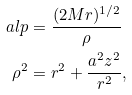Convert formula to latex. <formula><loc_0><loc_0><loc_500><loc_500>\ a l p & = \frac { ( 2 M r ) ^ { 1 / 2 } } { \rho } \\ \rho ^ { 2 } & = r ^ { 2 } + \frac { a ^ { 2 } z ^ { 2 } } { r ^ { 2 } } ,</formula> 